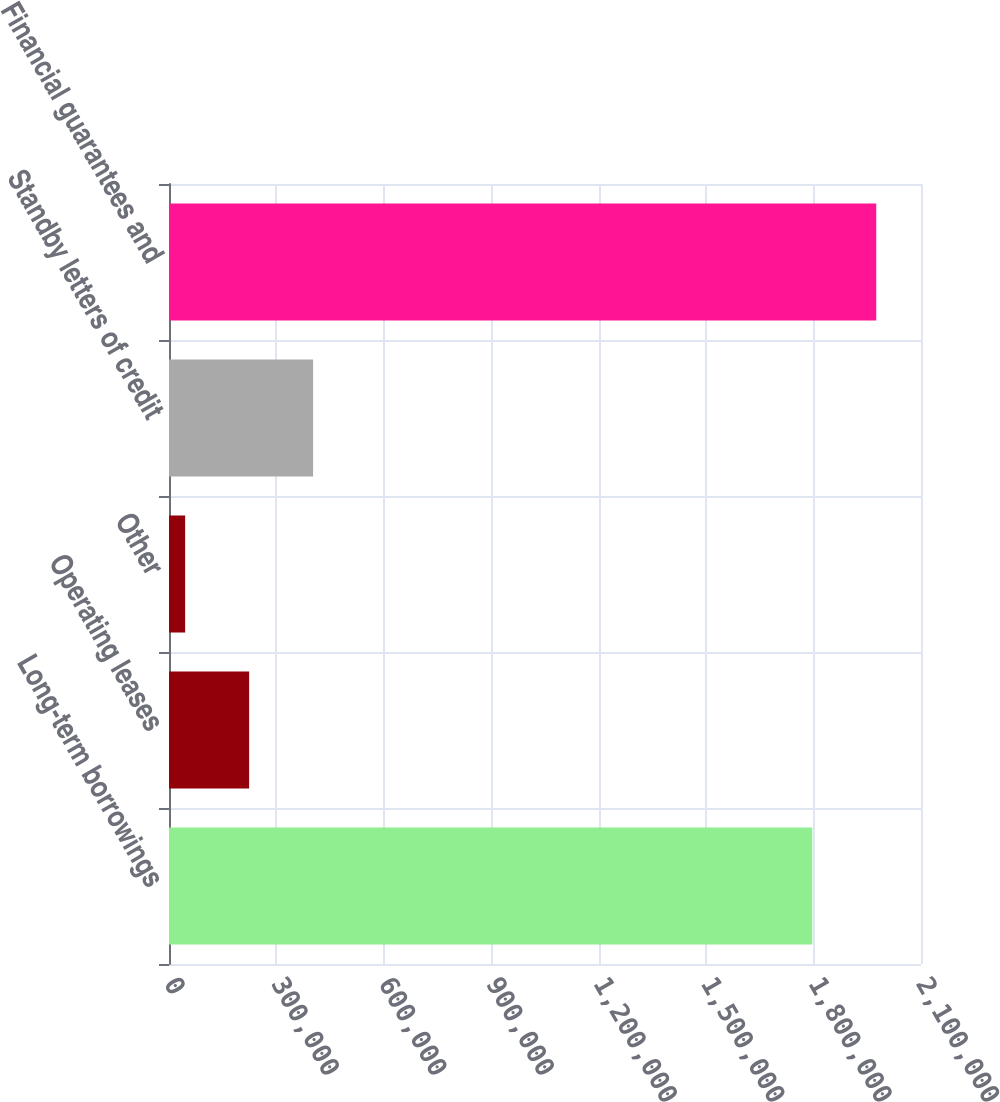Convert chart. <chart><loc_0><loc_0><loc_500><loc_500><bar_chart><fcel>Long-term borrowings<fcel>Operating leases<fcel>Other<fcel>Standby letters of credit<fcel>Financial guarantees and<nl><fcel>1.79636e+06<fcel>223752<fcel>45076<fcel>402427<fcel>1.97504e+06<nl></chart> 